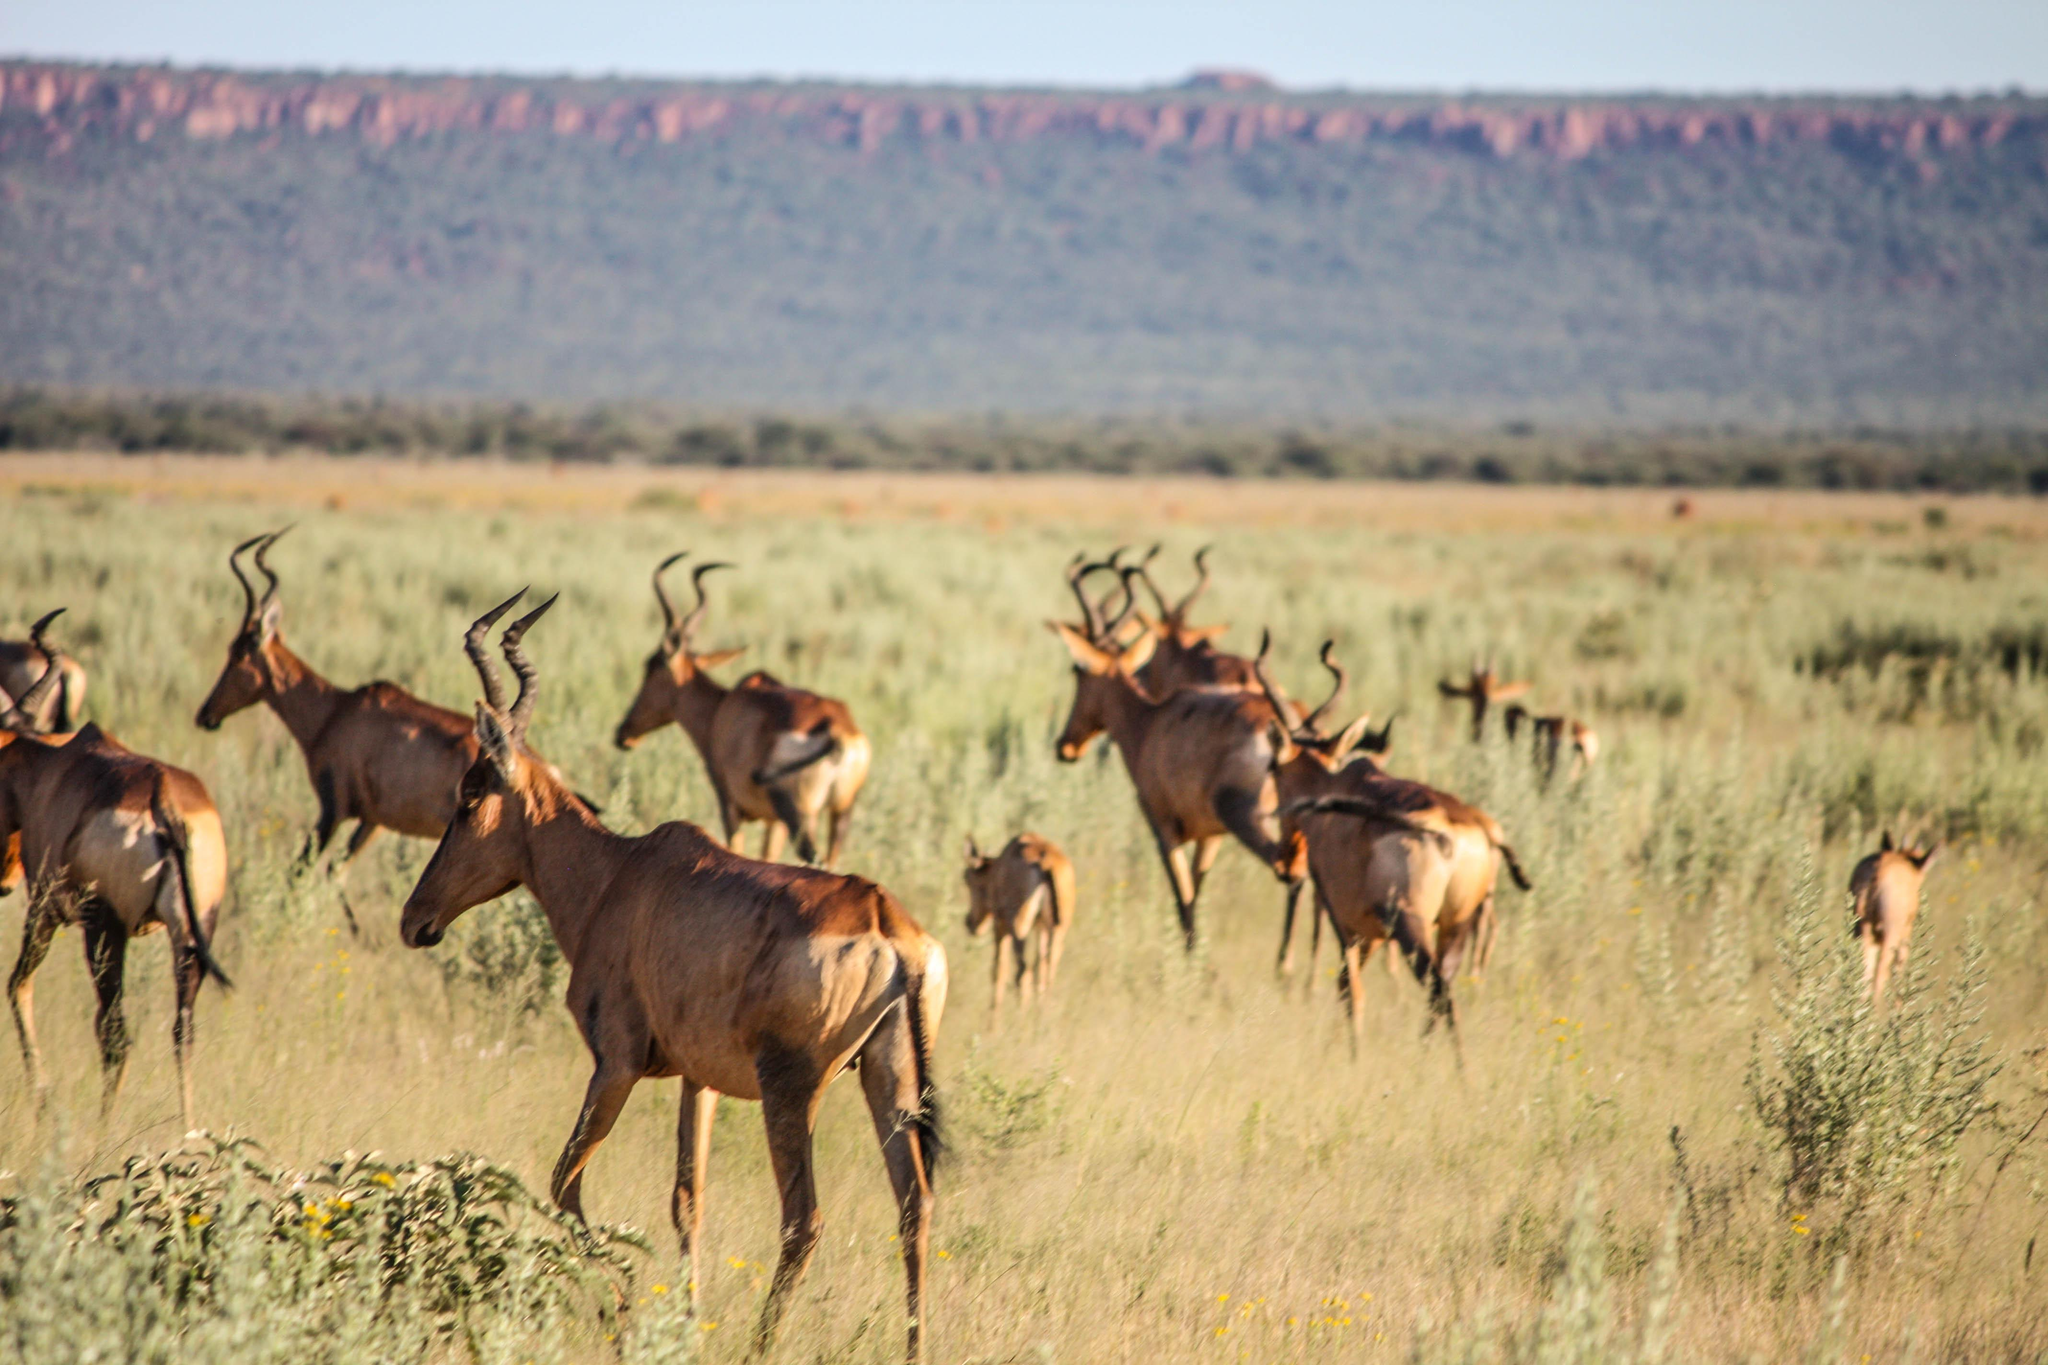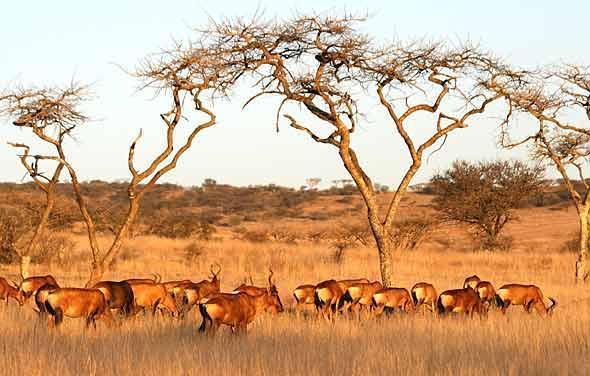The first image is the image on the left, the second image is the image on the right. Analyze the images presented: Is the assertion "There are five animals in the image on the right." valid? Answer yes or no. No. The first image is the image on the left, the second image is the image on the right. Assess this claim about the two images: "An image shows exactly five horned animals in reclining and standing poses, with no other mammals present.". Correct or not? Answer yes or no. No. 